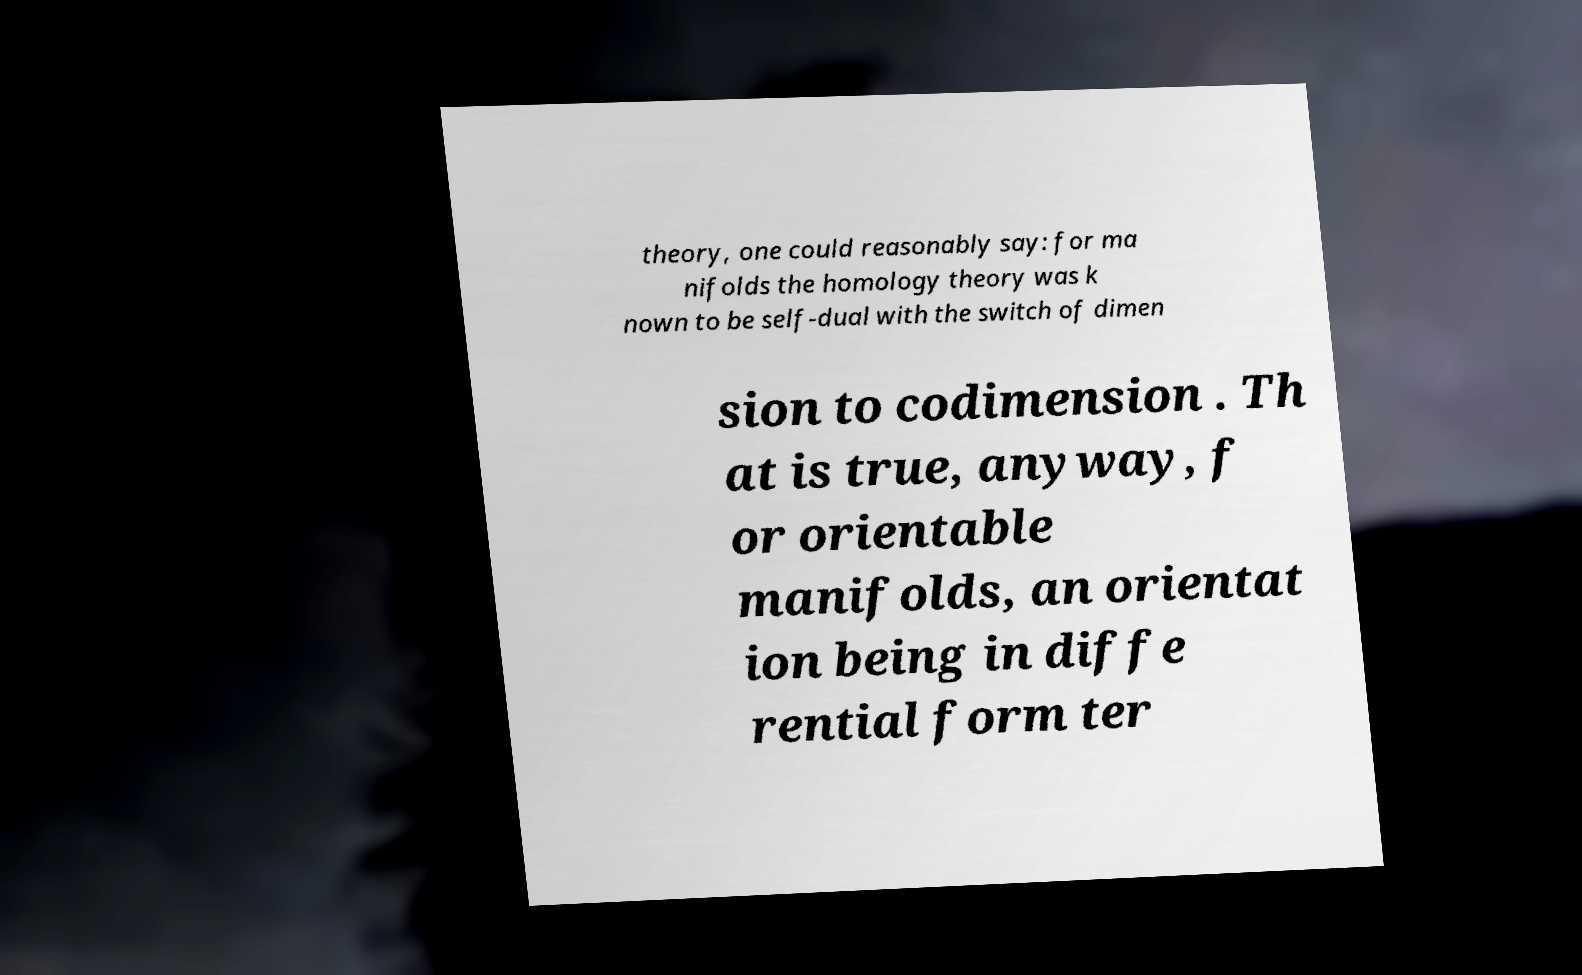There's text embedded in this image that I need extracted. Can you transcribe it verbatim? theory, one could reasonably say: for ma nifolds the homology theory was k nown to be self-dual with the switch of dimen sion to codimension . Th at is true, anyway, f or orientable manifolds, an orientat ion being in diffe rential form ter 